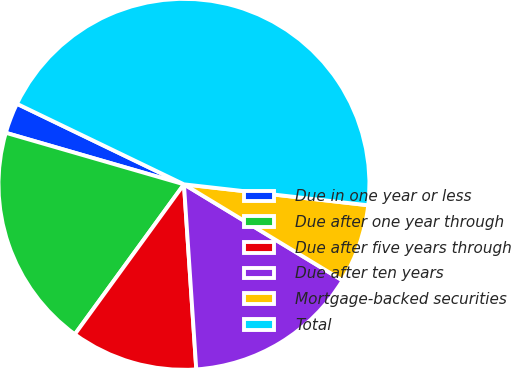<chart> <loc_0><loc_0><loc_500><loc_500><pie_chart><fcel>Due in one year or less<fcel>Due after one year through<fcel>Due after five years through<fcel>Due after ten years<fcel>Mortgage-backed securities<fcel>Total<nl><fcel>2.67%<fcel>19.47%<fcel>11.07%<fcel>15.27%<fcel>6.87%<fcel>44.65%<nl></chart> 